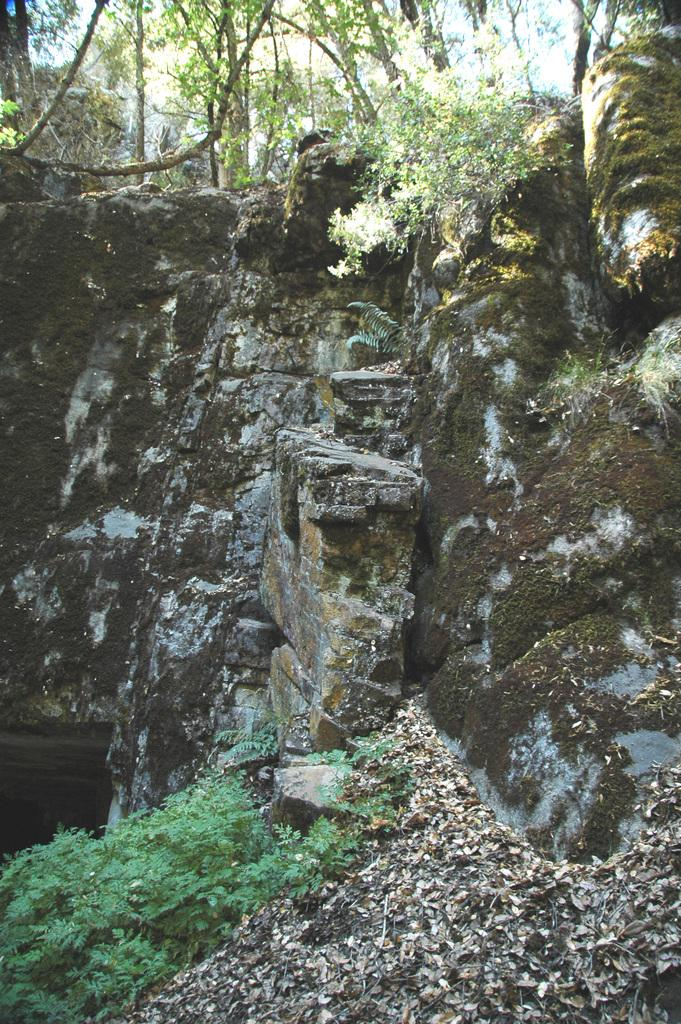What type of vegetation can be seen in the image? There are plants, trees, and grass visible in the image. What is on the ground in the image? There are leaves on the ground in the image. What is the terrain like in the image? There is a hill in the image. What part of the natural environment is visible in the image? The sky is visible in the image. Can you see any jelly on the hill in the image? There is no jelly present in the image. What type of stocking is hanging from the tree in the image? There is no stocking hanging from the tree in the image. 